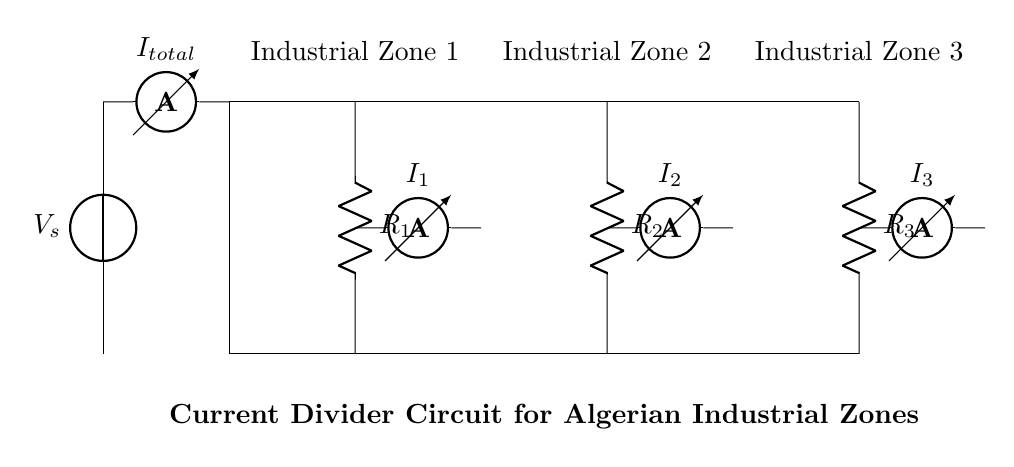What is the total current in the circuit? The total current, labeled as I_total, is provided directly in the circuit diagram connected to the ammeter. It represents the sum of all currents flowing through the branches.
Answer: I_total What are the resistor values in the circuit? The circuit diagram shows three resistors: R_1, R_2, and R_3 connected in parallel. Each resistor's value is denoted by its label, separating them into different industrial zones.
Answer: R_1, R_2, R_3 In which zones are the current measurements taken? The current measurements are indicated by the ammeters I_1, I_2, and I_3, which are located in the respective branches for Industrial Zones 1, 2, and 3.
Answer: Industrial Zones 1, 2, 3 How does current get allocated to each industrial zone? The current is allocated according to the resistance of each branch, following the current divider principle, where the current through each resistor is inversely proportional to its resistance. This means lower resistance will have a higher current.
Answer: Inversely proportional to resistance What is the function of the current divider in this circuit? The current divider's function is to distribute the total current from the source among the parallel branches, allowing each zone to receive a proportionate share based on its resistance.
Answer: Distributing total current What type of circuit is depicted in this diagram? The diagram represents a parallel circuit, characterized by multiple branches connected across the same voltage source. Each branch can operate independently with its resistance.
Answer: Parallel circuit 